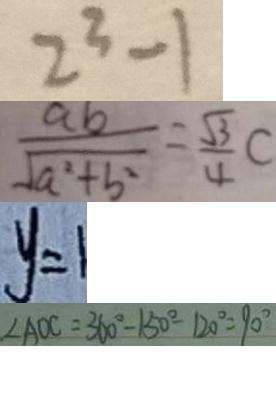Convert formula to latex. <formula><loc_0><loc_0><loc_500><loc_500>2 ^ { 3 } - 1 
 \frac { a b } { \sqrt { a ^ { 2 } + b ^ { 2 } } } = \frac { \sqrt { 3 } } { 4 } C 
 y = 1 
 \angle A O C = 3 6 0 ^ { \circ } - 1 5 0 ^ { \circ } - 1 2 0 ^ { \circ } = 9 0 ^ { \circ }</formula> 